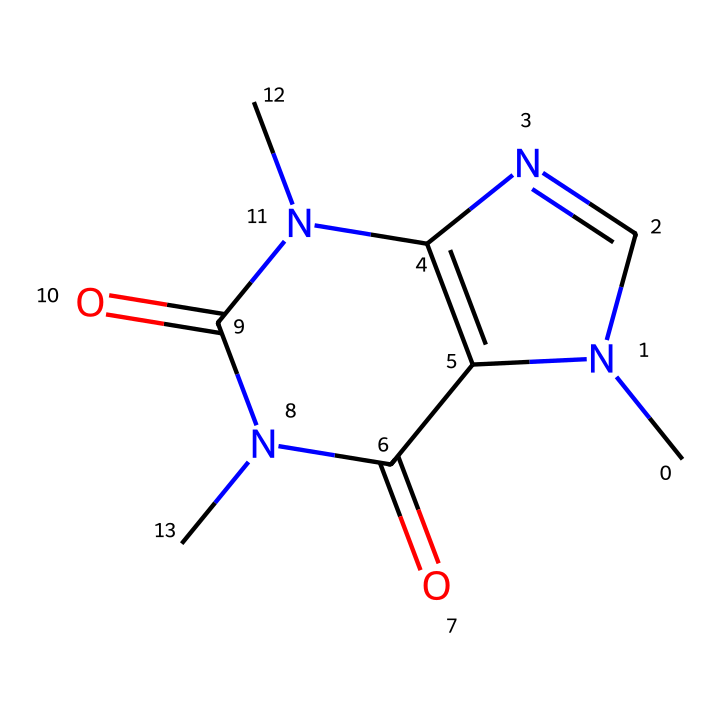What is the molecular formula of caffeine? The molecular formula can be determined by counting the number of each type of atom in the chemical structure. From the SMILES representation, we can identify 8 carbon (C), 10 hydrogen (H), 4 nitrogen (N), and 2 oxygen (O) atoms, leading to the formula C8H10N4O2.
Answer: C8H10N4O2 How many rings are present in the caffeine structure? By analyzing the SMILES structure, we can see that it contains two nitrogen atoms involved in ring structures (with the 'N' indicating that it is part of a ring system). Counting these, we find there are 2 rings in the caffeine structure.
Answer: 2 What type of isomerism is caffeine known for? Caffeine exhibits geometric isomerism due to the presence of double bonds and restricted rotation around these bonds, which allows for different spatial arrangements of its atoms.
Answer: geometric isomerism What is the effect of geometric isomers of caffeine on its bioavailability? Different geometric isomers can interact differently with biological receptors, potentially affecting the rate and extent of absorption into the bloodstream. Hence, this can lead to variations in bioavailability among these isomers.
Answer: variations in bioavailability Which geometric isomer of caffeine is preferred for energy drinks? The particular geometric isomer that is most effective for enhancing energy levels in drinks is typically the one that binds most favorably to adenosine receptors in the brain, thus optimizing stimulatory effects.
Answer: the preferred isomer How does the presence of nitrogen in caffeine contribute to its properties? The nitrogen atoms in caffeine contribute to its basicity and ability to form hydrogen bonds, which are critical for its interaction with biological systems and influence its stimulatory effects.
Answer: basicity and hydrogen bonds What is the significance of geometric isomers in the formulation of energy drinks? Including different geometric isomers may enhance the overall effectiveness of the energy drink in stimulating cognitive and physical performance by altering the pharmacokinetics of caffeine.
Answer: enhances effectiveness 